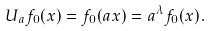<formula> <loc_0><loc_0><loc_500><loc_500>U _ { a } f _ { 0 } ( x ) = f _ { 0 } ( a x ) = a ^ { \lambda } f _ { 0 } ( x ) .</formula> 